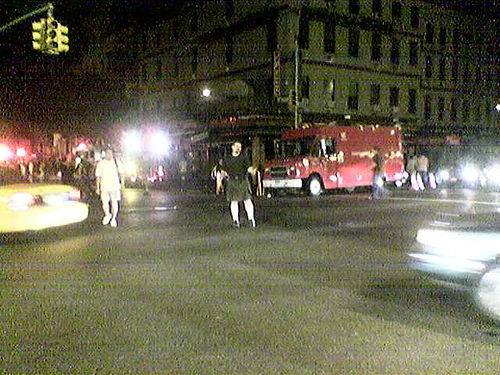Describe the objects in this image and their specific colors. I can see truck in black, brown, lightpink, and white tones, car in black, white, darkgray, and gray tones, car in black, ivory, khaki, gray, and tan tones, people in black, gray, ivory, and darkgreen tones, and people in black, ivory, darkgray, and tan tones in this image. 